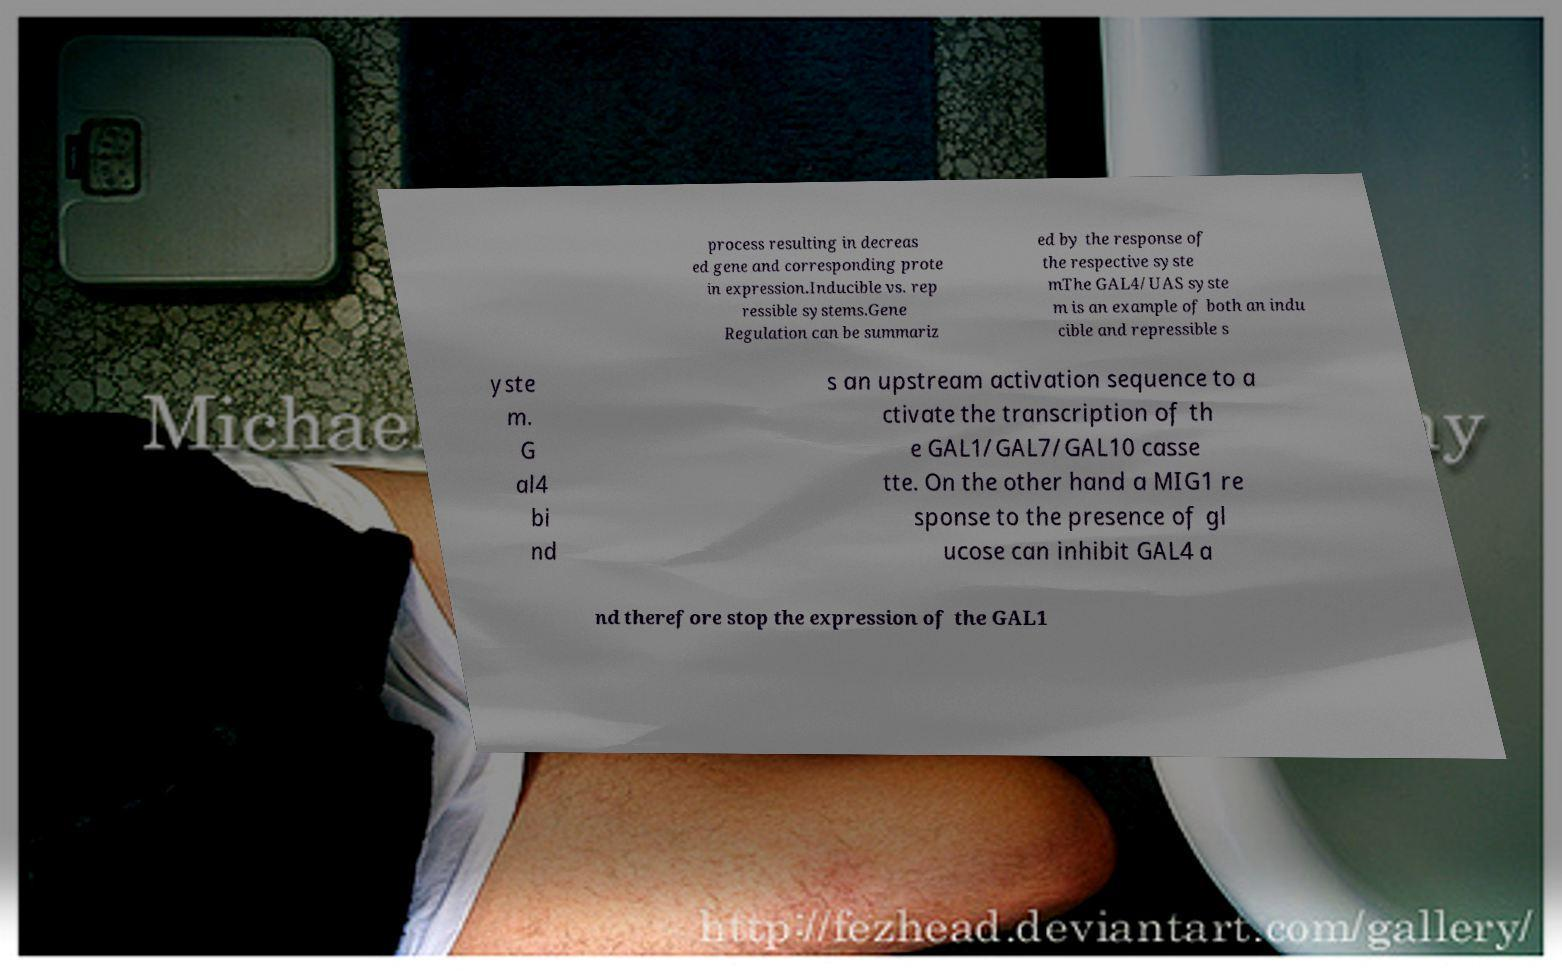Please identify and transcribe the text found in this image. process resulting in decreas ed gene and corresponding prote in expression.Inducible vs. rep ressible systems.Gene Regulation can be summariz ed by the response of the respective syste mThe GAL4/UAS syste m is an example of both an indu cible and repressible s yste m. G al4 bi nd s an upstream activation sequence to a ctivate the transcription of th e GAL1/GAL7/GAL10 casse tte. On the other hand a MIG1 re sponse to the presence of gl ucose can inhibit GAL4 a nd therefore stop the expression of the GAL1 